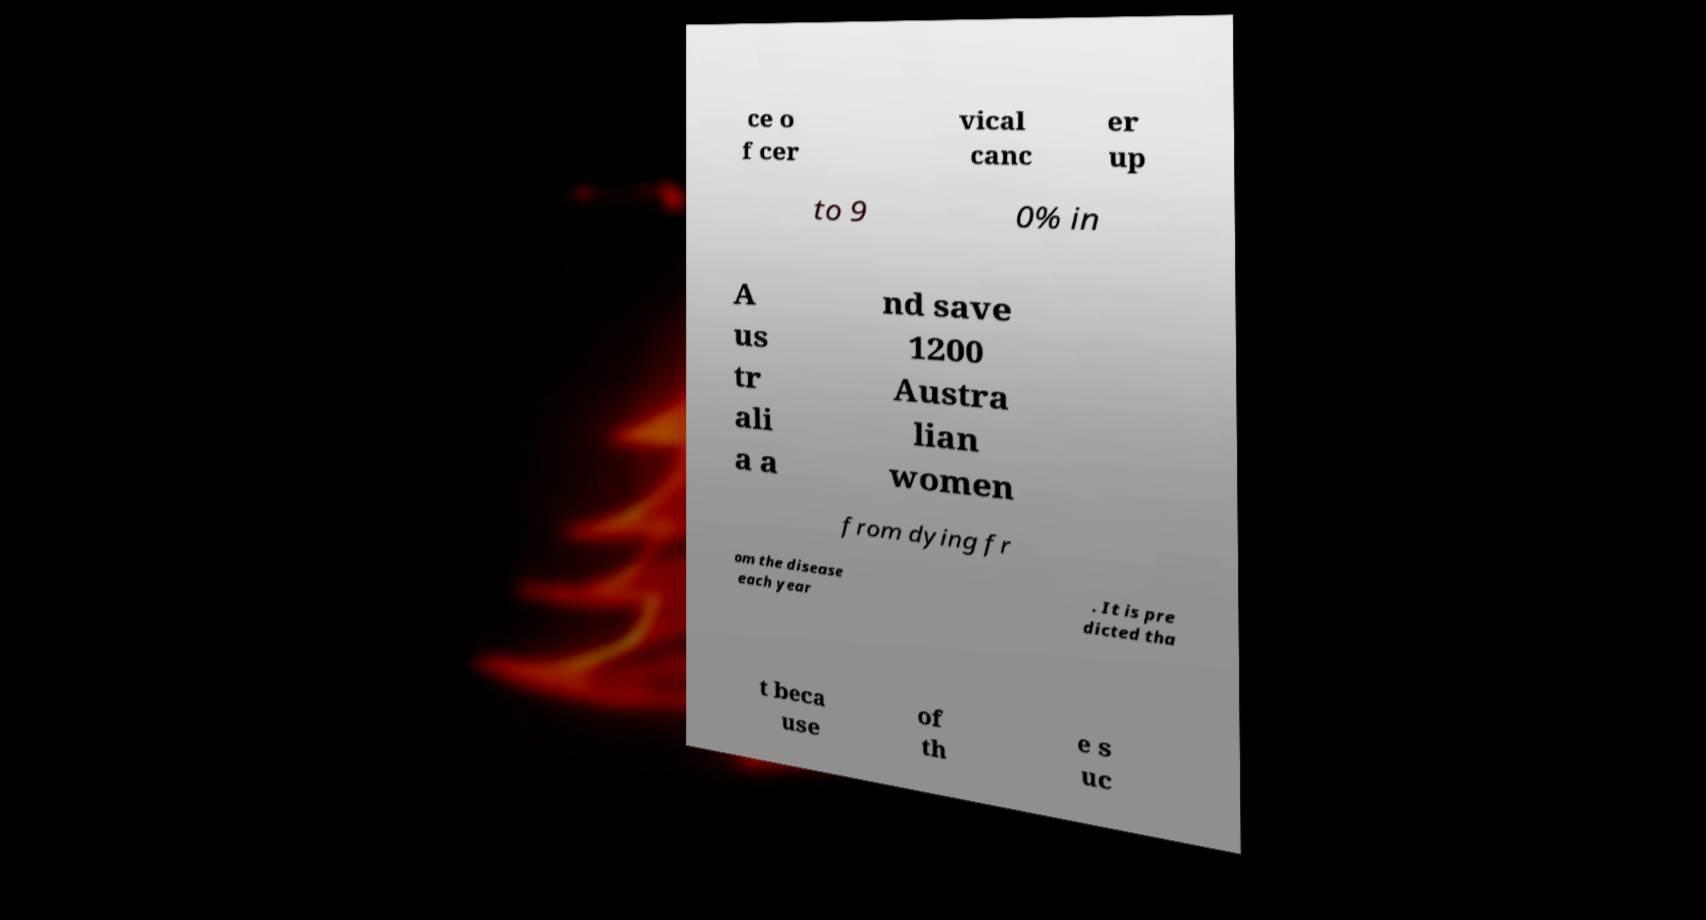For documentation purposes, I need the text within this image transcribed. Could you provide that? ce o f cer vical canc er up to 9 0% in A us tr ali a a nd save 1200 Austra lian women from dying fr om the disease each year . It is pre dicted tha t beca use of th e s uc 